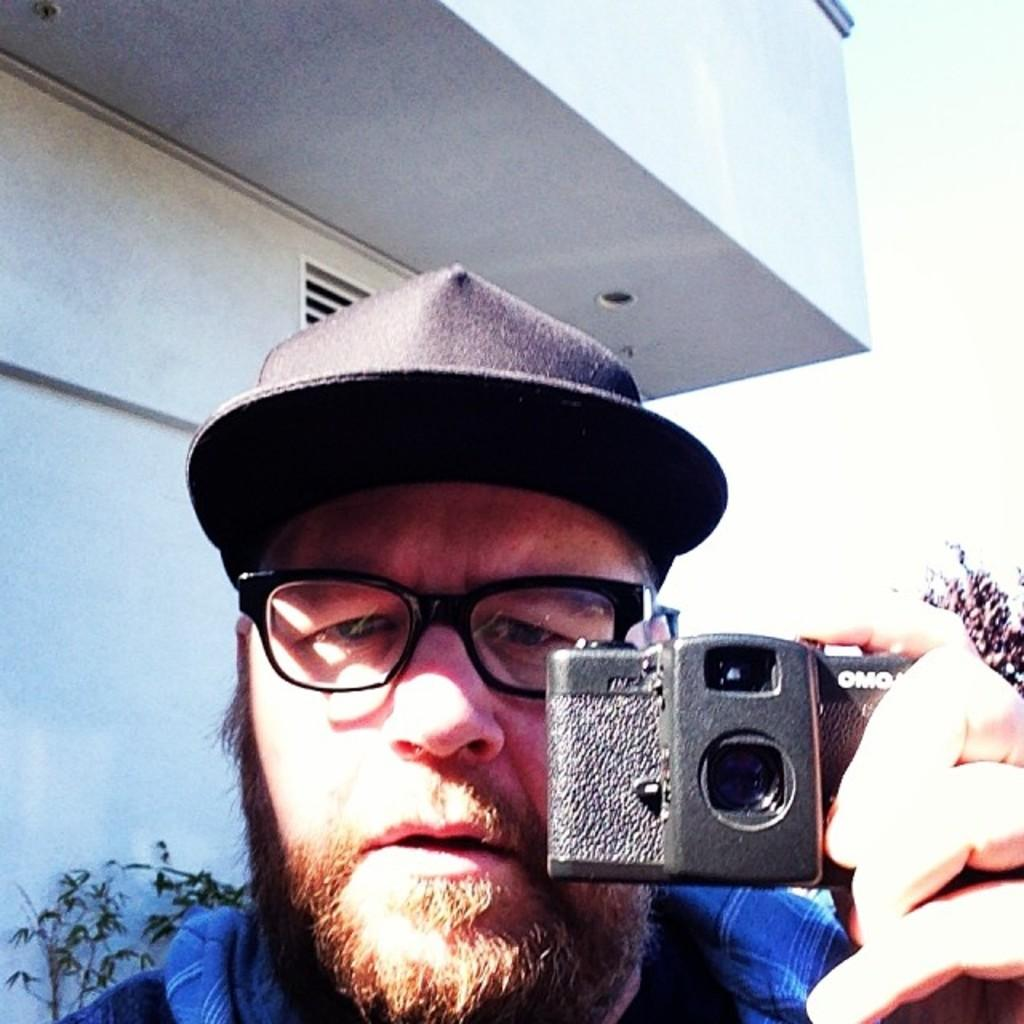Who is present in the image? There is a man in the image. What is the man holding in his hand? The man is holding a camera in his hand. What can be seen in the background of the image? There is a building visible in the background of the image. What type of battle is taking place in the image? There is no battle present in the image; it features a man holding a camera and a building in the background. How many dolls can be seen in the image? There are no dolls present in the image. 